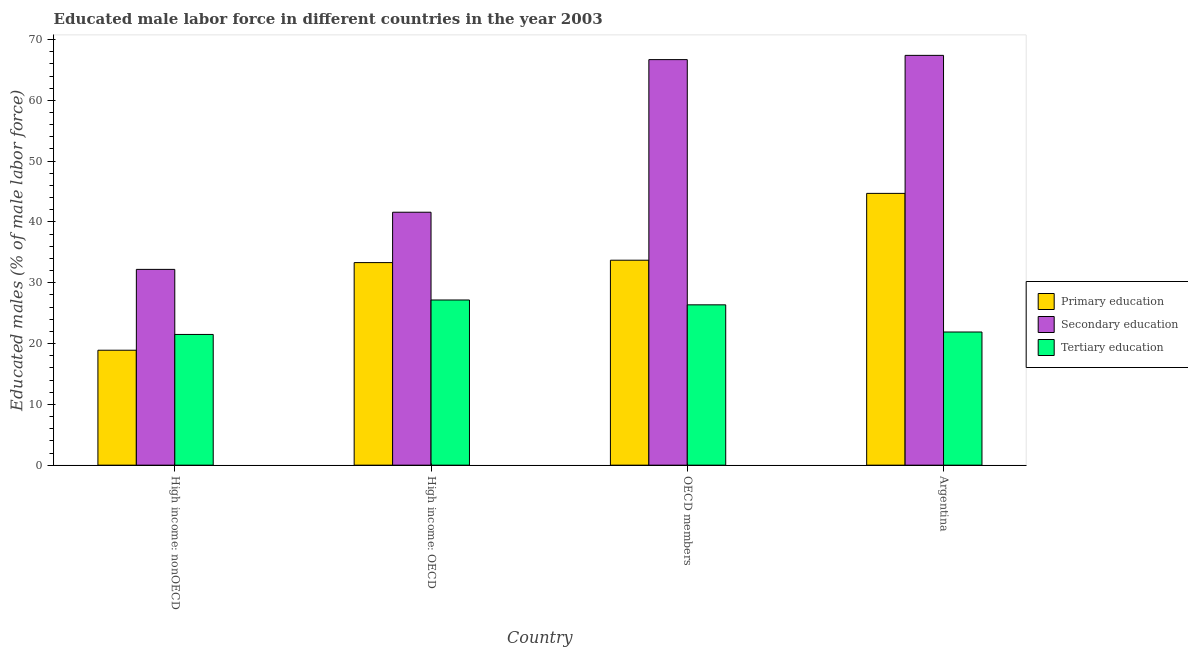How many different coloured bars are there?
Offer a terse response. 3. How many groups of bars are there?
Provide a succinct answer. 4. Are the number of bars per tick equal to the number of legend labels?
Ensure brevity in your answer.  Yes. What is the label of the 2nd group of bars from the left?
Your response must be concise. High income: OECD. In how many cases, is the number of bars for a given country not equal to the number of legend labels?
Provide a short and direct response. 0. What is the percentage of male labor force who received secondary education in High income: nonOECD?
Offer a terse response. 32.2. Across all countries, what is the maximum percentage of male labor force who received secondary education?
Ensure brevity in your answer.  67.4. Across all countries, what is the minimum percentage of male labor force who received secondary education?
Provide a short and direct response. 32.2. In which country was the percentage of male labor force who received primary education maximum?
Keep it short and to the point. Argentina. In which country was the percentage of male labor force who received primary education minimum?
Give a very brief answer. High income: nonOECD. What is the total percentage of male labor force who received primary education in the graph?
Ensure brevity in your answer.  130.63. What is the difference between the percentage of male labor force who received tertiary education in High income: OECD and that in OECD members?
Your answer should be very brief. 0.8. What is the difference between the percentage of male labor force who received tertiary education in Argentina and the percentage of male labor force who received secondary education in OECD members?
Offer a terse response. -44.8. What is the average percentage of male labor force who received tertiary education per country?
Make the answer very short. 24.23. What is the difference between the percentage of male labor force who received secondary education and percentage of male labor force who received primary education in Argentina?
Keep it short and to the point. 22.7. In how many countries, is the percentage of male labor force who received primary education greater than 10 %?
Make the answer very short. 4. What is the ratio of the percentage of male labor force who received tertiary education in Argentina to that in High income: OECD?
Give a very brief answer. 0.81. What is the difference between the highest and the second highest percentage of male labor force who received tertiary education?
Your response must be concise. 0.8. What is the difference between the highest and the lowest percentage of male labor force who received primary education?
Offer a very short reply. 25.8. In how many countries, is the percentage of male labor force who received primary education greater than the average percentage of male labor force who received primary education taken over all countries?
Keep it short and to the point. 3. How many bars are there?
Your answer should be compact. 12. Are all the bars in the graph horizontal?
Offer a very short reply. No. How many countries are there in the graph?
Keep it short and to the point. 4. What is the difference between two consecutive major ticks on the Y-axis?
Offer a terse response. 10. Does the graph contain any zero values?
Make the answer very short. No. Does the graph contain grids?
Provide a short and direct response. No. Where does the legend appear in the graph?
Offer a terse response. Center right. How many legend labels are there?
Make the answer very short. 3. How are the legend labels stacked?
Offer a terse response. Vertical. What is the title of the graph?
Give a very brief answer. Educated male labor force in different countries in the year 2003. Does "Transport equipments" appear as one of the legend labels in the graph?
Offer a very short reply. No. What is the label or title of the Y-axis?
Your response must be concise. Educated males (% of male labor force). What is the Educated males (% of male labor force) of Primary education in High income: nonOECD?
Your response must be concise. 18.9. What is the Educated males (% of male labor force) in Secondary education in High income: nonOECD?
Your answer should be compact. 32.2. What is the Educated males (% of male labor force) in Tertiary education in High income: nonOECD?
Ensure brevity in your answer.  21.5. What is the Educated males (% of male labor force) in Primary education in High income: OECD?
Ensure brevity in your answer.  33.31. What is the Educated males (% of male labor force) of Secondary education in High income: OECD?
Make the answer very short. 41.6. What is the Educated males (% of male labor force) of Tertiary education in High income: OECD?
Keep it short and to the point. 27.17. What is the Educated males (% of male labor force) in Primary education in OECD members?
Offer a terse response. 33.71. What is the Educated males (% of male labor force) of Secondary education in OECD members?
Make the answer very short. 66.7. What is the Educated males (% of male labor force) of Tertiary education in OECD members?
Ensure brevity in your answer.  26.37. What is the Educated males (% of male labor force) in Primary education in Argentina?
Provide a succinct answer. 44.7. What is the Educated males (% of male labor force) in Secondary education in Argentina?
Give a very brief answer. 67.4. What is the Educated males (% of male labor force) of Tertiary education in Argentina?
Your answer should be very brief. 21.9. Across all countries, what is the maximum Educated males (% of male labor force) of Primary education?
Offer a very short reply. 44.7. Across all countries, what is the maximum Educated males (% of male labor force) of Secondary education?
Make the answer very short. 67.4. Across all countries, what is the maximum Educated males (% of male labor force) in Tertiary education?
Provide a short and direct response. 27.17. Across all countries, what is the minimum Educated males (% of male labor force) of Primary education?
Provide a succinct answer. 18.9. Across all countries, what is the minimum Educated males (% of male labor force) of Secondary education?
Provide a short and direct response. 32.2. Across all countries, what is the minimum Educated males (% of male labor force) of Tertiary education?
Offer a terse response. 21.5. What is the total Educated males (% of male labor force) in Primary education in the graph?
Offer a terse response. 130.63. What is the total Educated males (% of male labor force) in Secondary education in the graph?
Give a very brief answer. 207.9. What is the total Educated males (% of male labor force) in Tertiary education in the graph?
Ensure brevity in your answer.  96.94. What is the difference between the Educated males (% of male labor force) of Primary education in High income: nonOECD and that in High income: OECD?
Your answer should be very brief. -14.41. What is the difference between the Educated males (% of male labor force) in Secondary education in High income: nonOECD and that in High income: OECD?
Your response must be concise. -9.4. What is the difference between the Educated males (% of male labor force) of Tertiary education in High income: nonOECD and that in High income: OECD?
Make the answer very short. -5.67. What is the difference between the Educated males (% of male labor force) of Primary education in High income: nonOECD and that in OECD members?
Your response must be concise. -14.81. What is the difference between the Educated males (% of male labor force) in Secondary education in High income: nonOECD and that in OECD members?
Your answer should be compact. -34.5. What is the difference between the Educated males (% of male labor force) of Tertiary education in High income: nonOECD and that in OECD members?
Keep it short and to the point. -4.87. What is the difference between the Educated males (% of male labor force) in Primary education in High income: nonOECD and that in Argentina?
Your answer should be very brief. -25.8. What is the difference between the Educated males (% of male labor force) of Secondary education in High income: nonOECD and that in Argentina?
Give a very brief answer. -35.2. What is the difference between the Educated males (% of male labor force) of Tertiary education in High income: nonOECD and that in Argentina?
Provide a short and direct response. -0.4. What is the difference between the Educated males (% of male labor force) in Primary education in High income: OECD and that in OECD members?
Offer a very short reply. -0.39. What is the difference between the Educated males (% of male labor force) in Secondary education in High income: OECD and that in OECD members?
Your response must be concise. -25.1. What is the difference between the Educated males (% of male labor force) in Tertiary education in High income: OECD and that in OECD members?
Provide a short and direct response. 0.8. What is the difference between the Educated males (% of male labor force) in Primary education in High income: OECD and that in Argentina?
Give a very brief answer. -11.39. What is the difference between the Educated males (% of male labor force) of Secondary education in High income: OECD and that in Argentina?
Keep it short and to the point. -25.8. What is the difference between the Educated males (% of male labor force) of Tertiary education in High income: OECD and that in Argentina?
Provide a short and direct response. 5.27. What is the difference between the Educated males (% of male labor force) in Primary education in OECD members and that in Argentina?
Offer a terse response. -10.99. What is the difference between the Educated males (% of male labor force) in Secondary education in OECD members and that in Argentina?
Make the answer very short. -0.7. What is the difference between the Educated males (% of male labor force) of Tertiary education in OECD members and that in Argentina?
Provide a succinct answer. 4.47. What is the difference between the Educated males (% of male labor force) of Primary education in High income: nonOECD and the Educated males (% of male labor force) of Secondary education in High income: OECD?
Provide a short and direct response. -22.7. What is the difference between the Educated males (% of male labor force) of Primary education in High income: nonOECD and the Educated males (% of male labor force) of Tertiary education in High income: OECD?
Your response must be concise. -8.26. What is the difference between the Educated males (% of male labor force) in Secondary education in High income: nonOECD and the Educated males (% of male labor force) in Tertiary education in High income: OECD?
Make the answer very short. 5.03. What is the difference between the Educated males (% of male labor force) in Primary education in High income: nonOECD and the Educated males (% of male labor force) in Secondary education in OECD members?
Ensure brevity in your answer.  -47.8. What is the difference between the Educated males (% of male labor force) in Primary education in High income: nonOECD and the Educated males (% of male labor force) in Tertiary education in OECD members?
Offer a terse response. -7.47. What is the difference between the Educated males (% of male labor force) of Secondary education in High income: nonOECD and the Educated males (% of male labor force) of Tertiary education in OECD members?
Give a very brief answer. 5.83. What is the difference between the Educated males (% of male labor force) of Primary education in High income: nonOECD and the Educated males (% of male labor force) of Secondary education in Argentina?
Keep it short and to the point. -48.5. What is the difference between the Educated males (% of male labor force) in Primary education in High income: nonOECD and the Educated males (% of male labor force) in Tertiary education in Argentina?
Ensure brevity in your answer.  -3. What is the difference between the Educated males (% of male labor force) of Primary education in High income: OECD and the Educated males (% of male labor force) of Secondary education in OECD members?
Offer a very short reply. -33.39. What is the difference between the Educated males (% of male labor force) of Primary education in High income: OECD and the Educated males (% of male labor force) of Tertiary education in OECD members?
Give a very brief answer. 6.94. What is the difference between the Educated males (% of male labor force) in Secondary education in High income: OECD and the Educated males (% of male labor force) in Tertiary education in OECD members?
Your response must be concise. 15.23. What is the difference between the Educated males (% of male labor force) in Primary education in High income: OECD and the Educated males (% of male labor force) in Secondary education in Argentina?
Your answer should be very brief. -34.09. What is the difference between the Educated males (% of male labor force) of Primary education in High income: OECD and the Educated males (% of male labor force) of Tertiary education in Argentina?
Offer a very short reply. 11.41. What is the difference between the Educated males (% of male labor force) of Primary education in OECD members and the Educated males (% of male labor force) of Secondary education in Argentina?
Offer a terse response. -33.69. What is the difference between the Educated males (% of male labor force) of Primary education in OECD members and the Educated males (% of male labor force) of Tertiary education in Argentina?
Offer a terse response. 11.81. What is the difference between the Educated males (% of male labor force) of Secondary education in OECD members and the Educated males (% of male labor force) of Tertiary education in Argentina?
Your answer should be very brief. 44.8. What is the average Educated males (% of male labor force) of Primary education per country?
Provide a short and direct response. 32.66. What is the average Educated males (% of male labor force) in Secondary education per country?
Offer a very short reply. 51.98. What is the average Educated males (% of male labor force) in Tertiary education per country?
Offer a very short reply. 24.23. What is the difference between the Educated males (% of male labor force) of Primary education and Educated males (% of male labor force) of Secondary education in High income: nonOECD?
Keep it short and to the point. -13.3. What is the difference between the Educated males (% of male labor force) in Primary education and Educated males (% of male labor force) in Tertiary education in High income: nonOECD?
Your response must be concise. -2.6. What is the difference between the Educated males (% of male labor force) in Secondary education and Educated males (% of male labor force) in Tertiary education in High income: nonOECD?
Give a very brief answer. 10.7. What is the difference between the Educated males (% of male labor force) in Primary education and Educated males (% of male labor force) in Secondary education in High income: OECD?
Offer a very short reply. -8.29. What is the difference between the Educated males (% of male labor force) in Primary education and Educated males (% of male labor force) in Tertiary education in High income: OECD?
Give a very brief answer. 6.15. What is the difference between the Educated males (% of male labor force) in Secondary education and Educated males (% of male labor force) in Tertiary education in High income: OECD?
Make the answer very short. 14.43. What is the difference between the Educated males (% of male labor force) of Primary education and Educated males (% of male labor force) of Secondary education in OECD members?
Provide a succinct answer. -32.99. What is the difference between the Educated males (% of male labor force) of Primary education and Educated males (% of male labor force) of Tertiary education in OECD members?
Ensure brevity in your answer.  7.34. What is the difference between the Educated males (% of male labor force) of Secondary education and Educated males (% of male labor force) of Tertiary education in OECD members?
Make the answer very short. 40.33. What is the difference between the Educated males (% of male labor force) of Primary education and Educated males (% of male labor force) of Secondary education in Argentina?
Your answer should be compact. -22.7. What is the difference between the Educated males (% of male labor force) of Primary education and Educated males (% of male labor force) of Tertiary education in Argentina?
Your response must be concise. 22.8. What is the difference between the Educated males (% of male labor force) in Secondary education and Educated males (% of male labor force) in Tertiary education in Argentina?
Ensure brevity in your answer.  45.5. What is the ratio of the Educated males (% of male labor force) of Primary education in High income: nonOECD to that in High income: OECD?
Provide a succinct answer. 0.57. What is the ratio of the Educated males (% of male labor force) of Secondary education in High income: nonOECD to that in High income: OECD?
Your answer should be compact. 0.77. What is the ratio of the Educated males (% of male labor force) in Tertiary education in High income: nonOECD to that in High income: OECD?
Ensure brevity in your answer.  0.79. What is the ratio of the Educated males (% of male labor force) of Primary education in High income: nonOECD to that in OECD members?
Provide a succinct answer. 0.56. What is the ratio of the Educated males (% of male labor force) in Secondary education in High income: nonOECD to that in OECD members?
Make the answer very short. 0.48. What is the ratio of the Educated males (% of male labor force) in Tertiary education in High income: nonOECD to that in OECD members?
Offer a terse response. 0.82. What is the ratio of the Educated males (% of male labor force) of Primary education in High income: nonOECD to that in Argentina?
Provide a short and direct response. 0.42. What is the ratio of the Educated males (% of male labor force) in Secondary education in High income: nonOECD to that in Argentina?
Your response must be concise. 0.48. What is the ratio of the Educated males (% of male labor force) in Tertiary education in High income: nonOECD to that in Argentina?
Keep it short and to the point. 0.98. What is the ratio of the Educated males (% of male labor force) of Primary education in High income: OECD to that in OECD members?
Offer a very short reply. 0.99. What is the ratio of the Educated males (% of male labor force) in Secondary education in High income: OECD to that in OECD members?
Your response must be concise. 0.62. What is the ratio of the Educated males (% of male labor force) of Tertiary education in High income: OECD to that in OECD members?
Offer a terse response. 1.03. What is the ratio of the Educated males (% of male labor force) in Primary education in High income: OECD to that in Argentina?
Your answer should be very brief. 0.75. What is the ratio of the Educated males (% of male labor force) of Secondary education in High income: OECD to that in Argentina?
Offer a very short reply. 0.62. What is the ratio of the Educated males (% of male labor force) in Tertiary education in High income: OECD to that in Argentina?
Give a very brief answer. 1.24. What is the ratio of the Educated males (% of male labor force) in Primary education in OECD members to that in Argentina?
Provide a short and direct response. 0.75. What is the ratio of the Educated males (% of male labor force) in Tertiary education in OECD members to that in Argentina?
Your answer should be very brief. 1.2. What is the difference between the highest and the second highest Educated males (% of male labor force) of Primary education?
Your answer should be compact. 10.99. What is the difference between the highest and the second highest Educated males (% of male labor force) of Secondary education?
Offer a terse response. 0.7. What is the difference between the highest and the second highest Educated males (% of male labor force) of Tertiary education?
Offer a very short reply. 0.8. What is the difference between the highest and the lowest Educated males (% of male labor force) of Primary education?
Your response must be concise. 25.8. What is the difference between the highest and the lowest Educated males (% of male labor force) of Secondary education?
Keep it short and to the point. 35.2. What is the difference between the highest and the lowest Educated males (% of male labor force) of Tertiary education?
Make the answer very short. 5.67. 